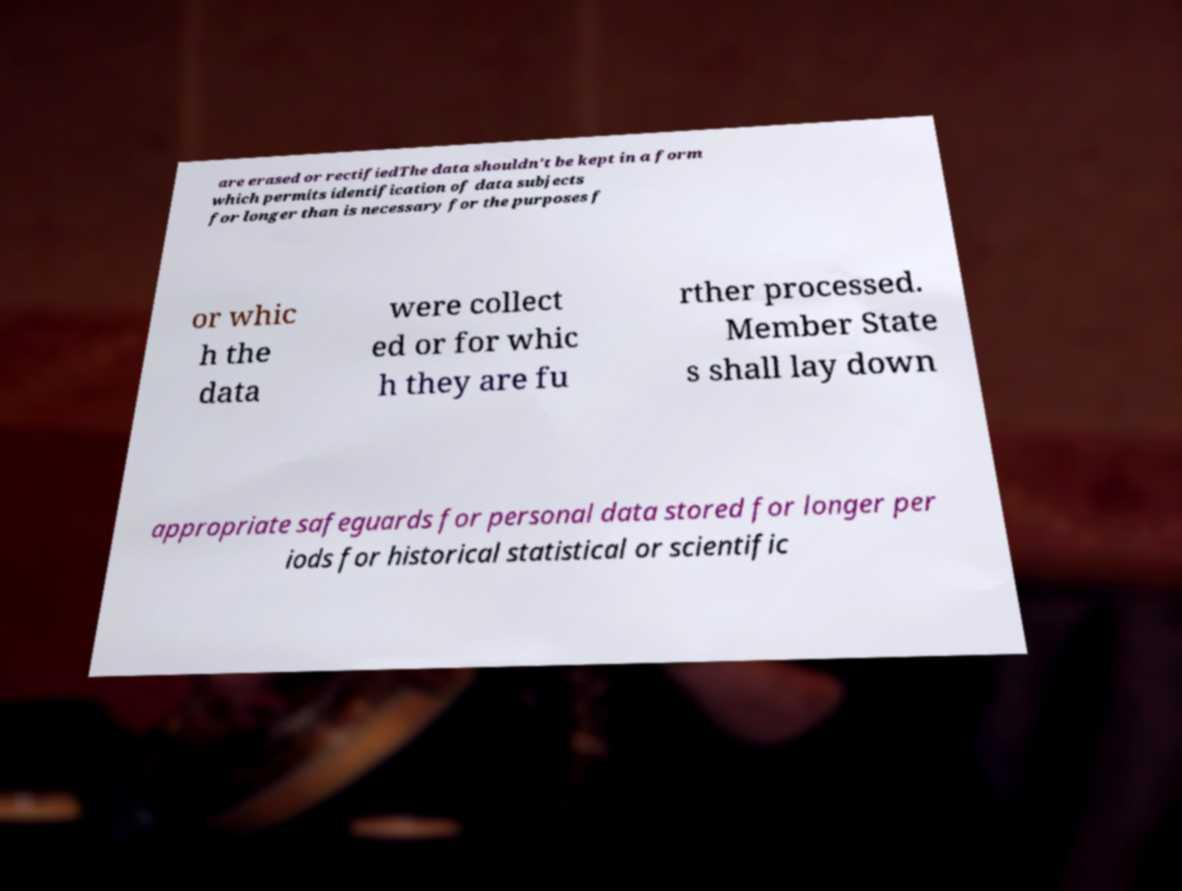For documentation purposes, I need the text within this image transcribed. Could you provide that? are erased or rectifiedThe data shouldn't be kept in a form which permits identification of data subjects for longer than is necessary for the purposes f or whic h the data were collect ed or for whic h they are fu rther processed. Member State s shall lay down appropriate safeguards for personal data stored for longer per iods for historical statistical or scientific 